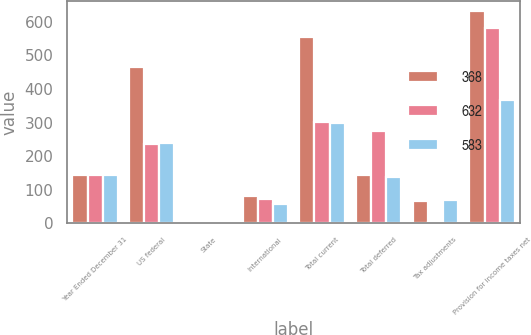<chart> <loc_0><loc_0><loc_500><loc_500><stacked_bar_chart><ecel><fcel>Year Ended December 31<fcel>US federal<fcel>State<fcel>International<fcel>Total current<fcel>Total deferred<fcel>Tax adjustments<fcel>Provision for income taxes net<nl><fcel>368<fcel>144<fcel>467<fcel>5<fcel>82<fcel>554<fcel>144<fcel>66<fcel>632<nl><fcel>632<fcel>144<fcel>235<fcel>5<fcel>73<fcel>303<fcel>276<fcel>4<fcel>583<nl><fcel>583<fcel>144<fcel>240<fcel>1<fcel>58<fcel>299<fcel>137<fcel>68<fcel>368<nl></chart> 